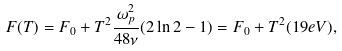<formula> <loc_0><loc_0><loc_500><loc_500>F ( T ) = F _ { 0 } + T ^ { 2 } \frac { \omega _ { p } ^ { 2 } } { 4 8 \nu } ( 2 \ln 2 - 1 ) = F _ { 0 } + T ^ { 2 } ( 1 9 e V ) ,</formula> 